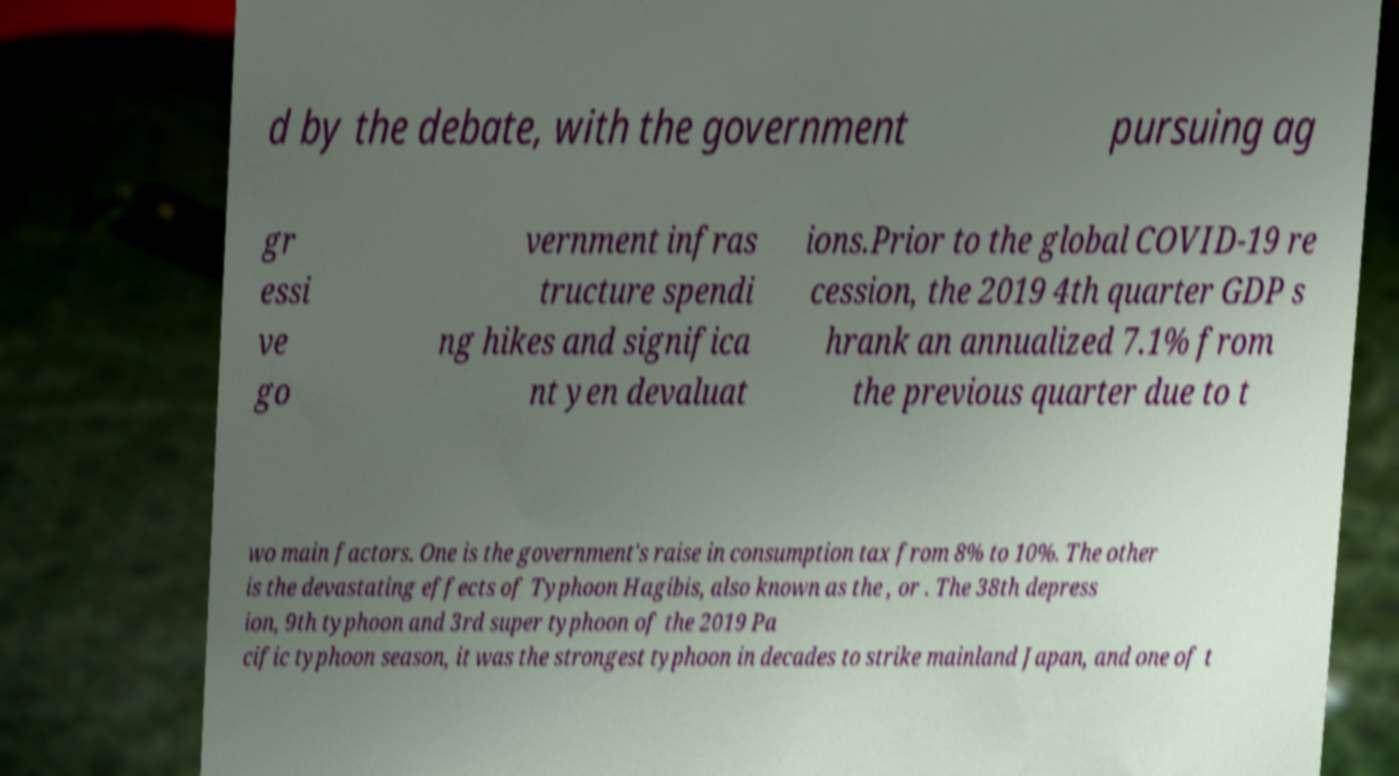What messages or text are displayed in this image? I need them in a readable, typed format. d by the debate, with the government pursuing ag gr essi ve go vernment infras tructure spendi ng hikes and significa nt yen devaluat ions.Prior to the global COVID-19 re cession, the 2019 4th quarter GDP s hrank an annualized 7.1% from the previous quarter due to t wo main factors. One is the government's raise in consumption tax from 8% to 10%. The other is the devastating effects of Typhoon Hagibis, also known as the , or . The 38th depress ion, 9th typhoon and 3rd super typhoon of the 2019 Pa cific typhoon season, it was the strongest typhoon in decades to strike mainland Japan, and one of t 